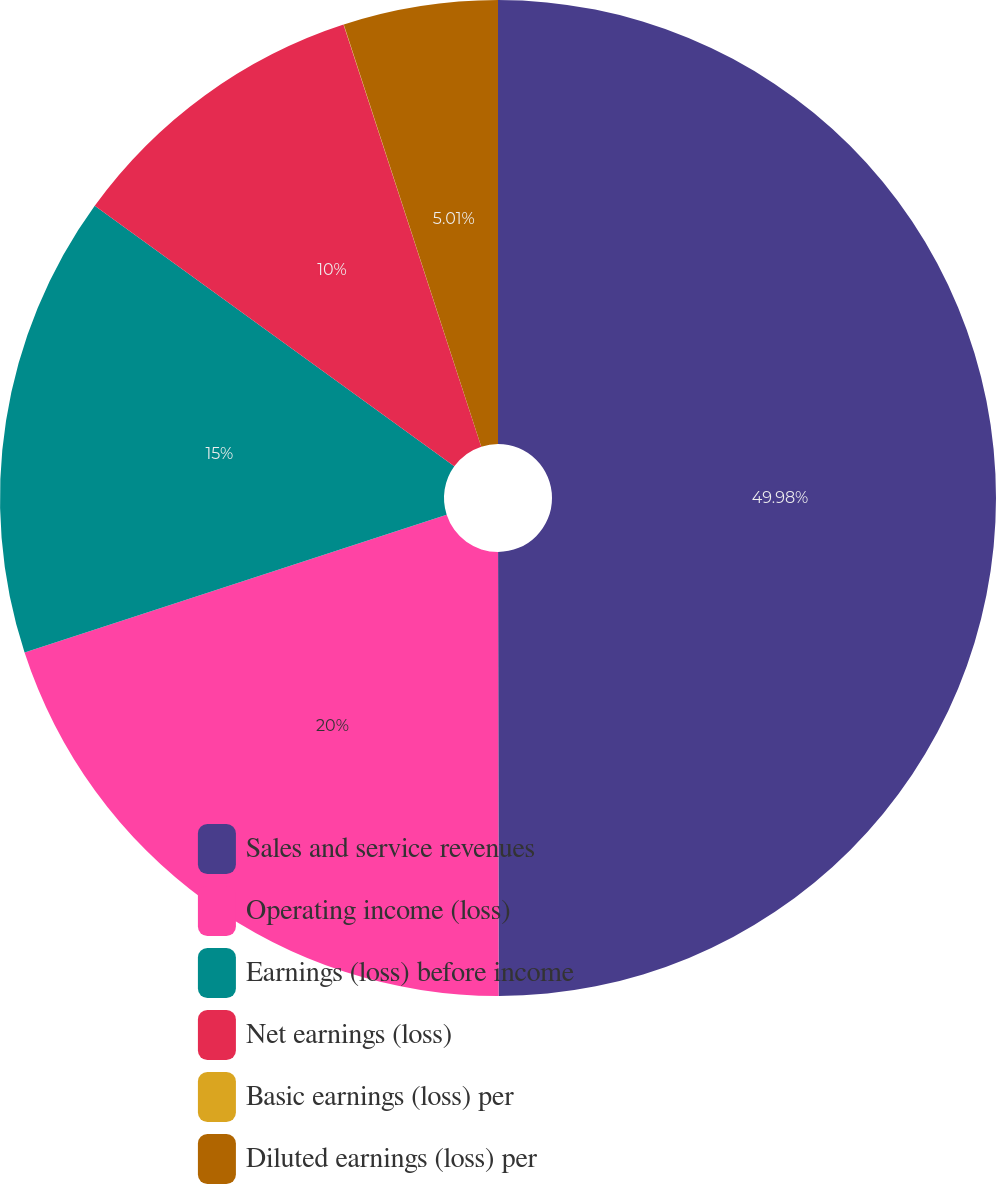<chart> <loc_0><loc_0><loc_500><loc_500><pie_chart><fcel>Sales and service revenues<fcel>Operating income (loss)<fcel>Earnings (loss) before income<fcel>Net earnings (loss)<fcel>Basic earnings (loss) per<fcel>Diluted earnings (loss) per<nl><fcel>49.98%<fcel>20.0%<fcel>15.0%<fcel>10.0%<fcel>0.01%<fcel>5.01%<nl></chart> 